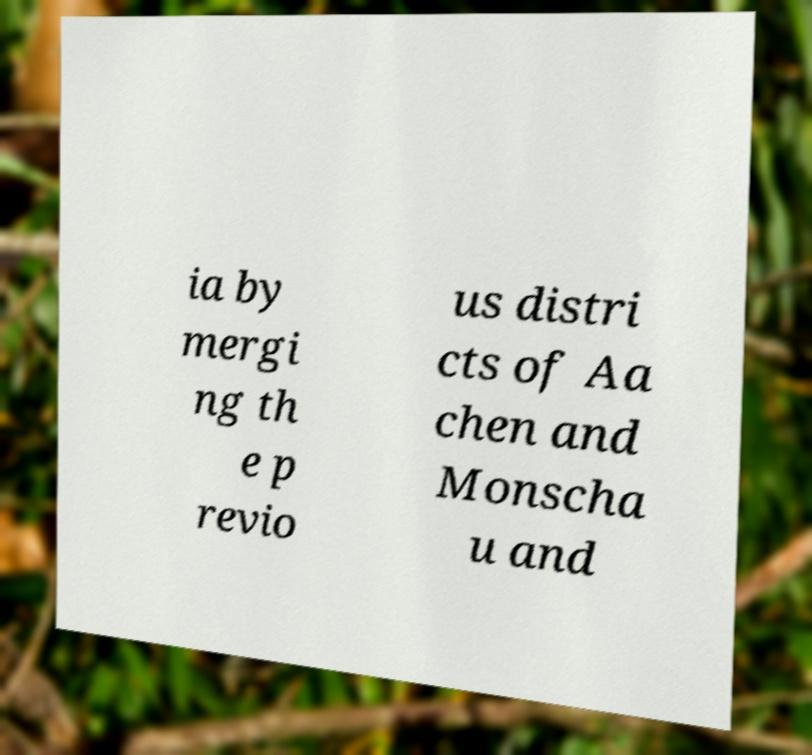Please read and relay the text visible in this image. What does it say? ia by mergi ng th e p revio us distri cts of Aa chen and Monscha u and 